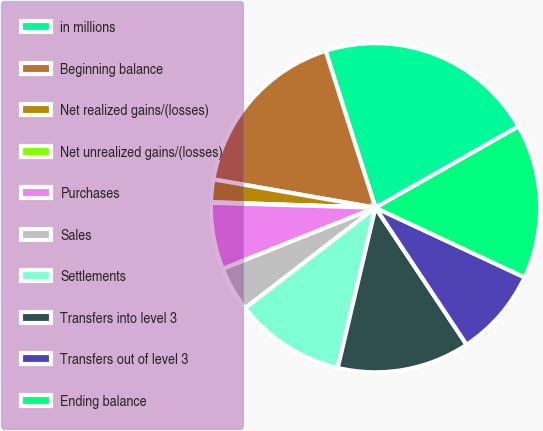<chart> <loc_0><loc_0><loc_500><loc_500><pie_chart><fcel>in millions<fcel>Beginning balance<fcel>Net realized gains/(losses)<fcel>Net unrealized gains/(losses)<fcel>Purchases<fcel>Sales<fcel>Settlements<fcel>Transfers into level 3<fcel>Transfers out of level 3<fcel>Ending balance<nl><fcel>21.66%<fcel>17.34%<fcel>2.22%<fcel>0.06%<fcel>6.54%<fcel>4.38%<fcel>10.86%<fcel>13.02%<fcel>8.7%<fcel>15.18%<nl></chart> 